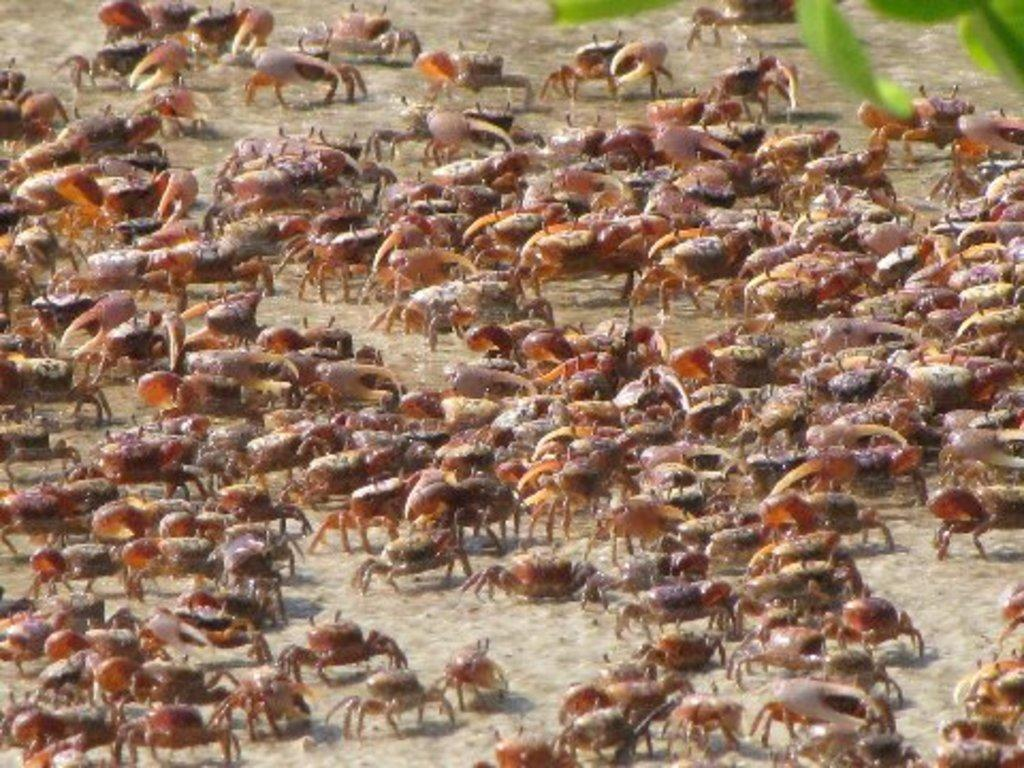What type of creatures are present in the image? There is a group of insects in the image. What surface are the insects on? The insects are on sand. What other natural elements can be seen in the image? Leaves are visible at the top of the image. How are the leaves positioned in the image? The leaves appear to be truncated. What type of debt is being discussed in the image? There is no mention or indication of debt in the image; it features a group of insects on sand with truncated leaves. 